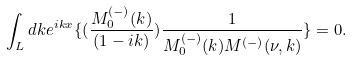Convert formula to latex. <formula><loc_0><loc_0><loc_500><loc_500>\int _ { L } d k e ^ { i k x } \{ ( \frac { M _ { 0 } ^ { ( - ) } ( k ) } { ( 1 - i k ) } ) \frac { 1 } { M _ { 0 } ^ { ( - ) } ( k ) M ^ { ( - ) } ( \nu , k ) } \} = 0 .</formula> 